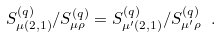<formula> <loc_0><loc_0><loc_500><loc_500>S ^ { ( q ) } _ { \mu ( 2 , 1 ) } / S ^ { ( q ) } _ { \mu \rho } = S ^ { ( q ) } _ { \mu ^ { \prime } ( 2 , 1 ) } / S ^ { ( q ) } _ { \mu ^ { \prime } \rho } \ .</formula> 